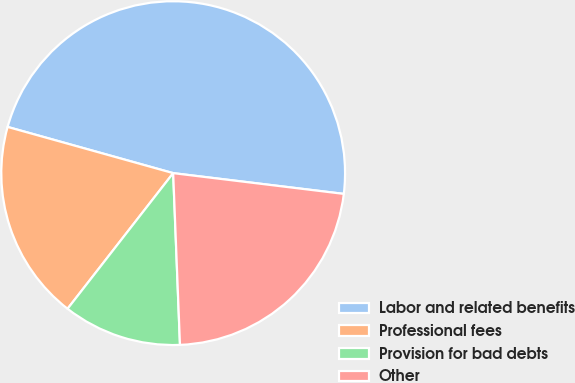Convert chart. <chart><loc_0><loc_0><loc_500><loc_500><pie_chart><fcel>Labor and related benefits<fcel>Professional fees<fcel>Provision for bad debts<fcel>Other<nl><fcel>47.59%<fcel>18.8%<fcel>11.16%<fcel>22.44%<nl></chart> 